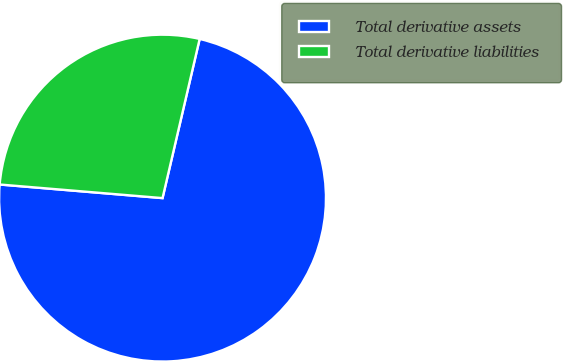Convert chart. <chart><loc_0><loc_0><loc_500><loc_500><pie_chart><fcel>Total derivative assets<fcel>Total derivative liabilities<nl><fcel>72.68%<fcel>27.32%<nl></chart> 